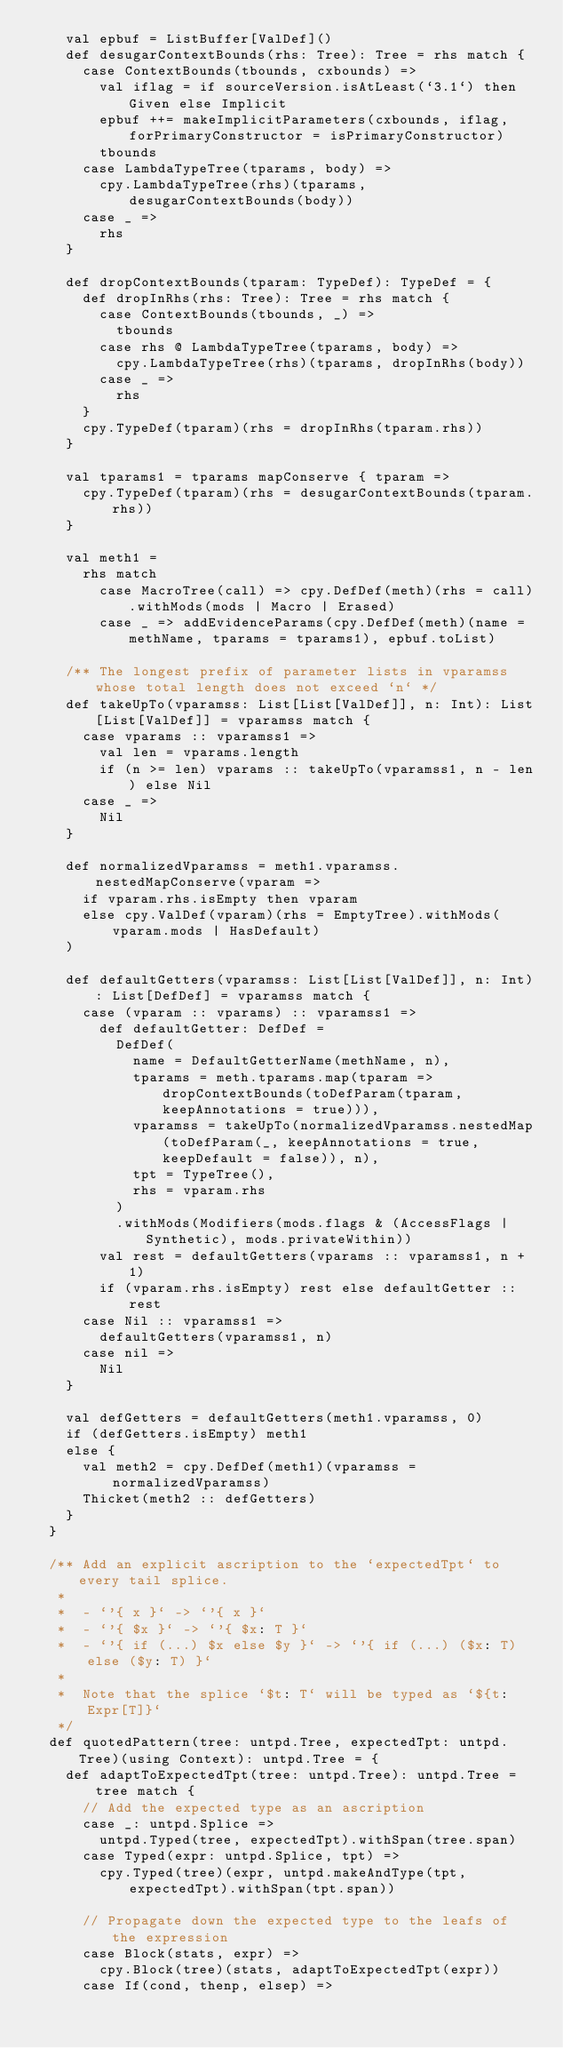<code> <loc_0><loc_0><loc_500><loc_500><_Scala_>    val epbuf = ListBuffer[ValDef]()
    def desugarContextBounds(rhs: Tree): Tree = rhs match {
      case ContextBounds(tbounds, cxbounds) =>
        val iflag = if sourceVersion.isAtLeast(`3.1`) then Given else Implicit
        epbuf ++= makeImplicitParameters(cxbounds, iflag, forPrimaryConstructor = isPrimaryConstructor)
        tbounds
      case LambdaTypeTree(tparams, body) =>
        cpy.LambdaTypeTree(rhs)(tparams, desugarContextBounds(body))
      case _ =>
        rhs
    }

    def dropContextBounds(tparam: TypeDef): TypeDef = {
      def dropInRhs(rhs: Tree): Tree = rhs match {
        case ContextBounds(tbounds, _) =>
          tbounds
        case rhs @ LambdaTypeTree(tparams, body) =>
          cpy.LambdaTypeTree(rhs)(tparams, dropInRhs(body))
        case _ =>
          rhs
      }
      cpy.TypeDef(tparam)(rhs = dropInRhs(tparam.rhs))
    }

    val tparams1 = tparams mapConserve { tparam =>
      cpy.TypeDef(tparam)(rhs = desugarContextBounds(tparam.rhs))
    }

    val meth1 =
      rhs match
        case MacroTree(call) => cpy.DefDef(meth)(rhs = call).withMods(mods | Macro | Erased)
        case _ => addEvidenceParams(cpy.DefDef(meth)(name = methName, tparams = tparams1), epbuf.toList)

    /** The longest prefix of parameter lists in vparamss whose total length does not exceed `n` */
    def takeUpTo(vparamss: List[List[ValDef]], n: Int): List[List[ValDef]] = vparamss match {
      case vparams :: vparamss1 =>
        val len = vparams.length
        if (n >= len) vparams :: takeUpTo(vparamss1, n - len) else Nil
      case _ =>
        Nil
    }

    def normalizedVparamss = meth1.vparamss.nestedMapConserve(vparam =>
      if vparam.rhs.isEmpty then vparam
      else cpy.ValDef(vparam)(rhs = EmptyTree).withMods(vparam.mods | HasDefault)
    )

    def defaultGetters(vparamss: List[List[ValDef]], n: Int): List[DefDef] = vparamss match {
      case (vparam :: vparams) :: vparamss1 =>
        def defaultGetter: DefDef =
          DefDef(
            name = DefaultGetterName(methName, n),
            tparams = meth.tparams.map(tparam => dropContextBounds(toDefParam(tparam, keepAnnotations = true))),
            vparamss = takeUpTo(normalizedVparamss.nestedMap(toDefParam(_, keepAnnotations = true, keepDefault = false)), n),
            tpt = TypeTree(),
            rhs = vparam.rhs
          )
          .withMods(Modifiers(mods.flags & (AccessFlags | Synthetic), mods.privateWithin))
        val rest = defaultGetters(vparams :: vparamss1, n + 1)
        if (vparam.rhs.isEmpty) rest else defaultGetter :: rest
      case Nil :: vparamss1 =>
        defaultGetters(vparamss1, n)
      case nil =>
        Nil
    }

    val defGetters = defaultGetters(meth1.vparamss, 0)
    if (defGetters.isEmpty) meth1
    else {
      val meth2 = cpy.DefDef(meth1)(vparamss = normalizedVparamss)
      Thicket(meth2 :: defGetters)
    }
  }

  /** Add an explicit ascription to the `expectedTpt` to every tail splice.
   *
   *  - `'{ x }` -> `'{ x }`
   *  - `'{ $x }` -> `'{ $x: T }`
   *  - `'{ if (...) $x else $y }` -> `'{ if (...) ($x: T) else ($y: T) }`
   *
   *  Note that the splice `$t: T` will be typed as `${t: Expr[T]}`
   */
  def quotedPattern(tree: untpd.Tree, expectedTpt: untpd.Tree)(using Context): untpd.Tree = {
    def adaptToExpectedTpt(tree: untpd.Tree): untpd.Tree = tree match {
      // Add the expected type as an ascription
      case _: untpd.Splice =>
        untpd.Typed(tree, expectedTpt).withSpan(tree.span)
      case Typed(expr: untpd.Splice, tpt) =>
        cpy.Typed(tree)(expr, untpd.makeAndType(tpt, expectedTpt).withSpan(tpt.span))

      // Propagate down the expected type to the leafs of the expression
      case Block(stats, expr) =>
        cpy.Block(tree)(stats, adaptToExpectedTpt(expr))
      case If(cond, thenp, elsep) =></code> 